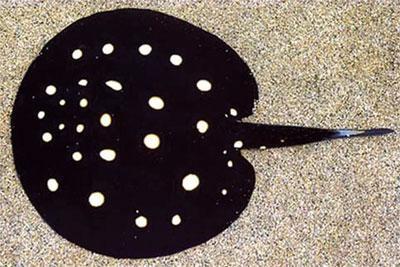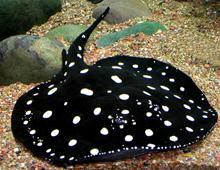The first image is the image on the left, the second image is the image on the right. Assess this claim about the two images: "Both stingrays have white spots and their tails are pointed in different directions.". Correct or not? Answer yes or no. Yes. The first image is the image on the left, the second image is the image on the right. For the images displayed, is the sentence "a spotted stingray is in water with a tan gravel bottom" factually correct? Answer yes or no. Yes. 